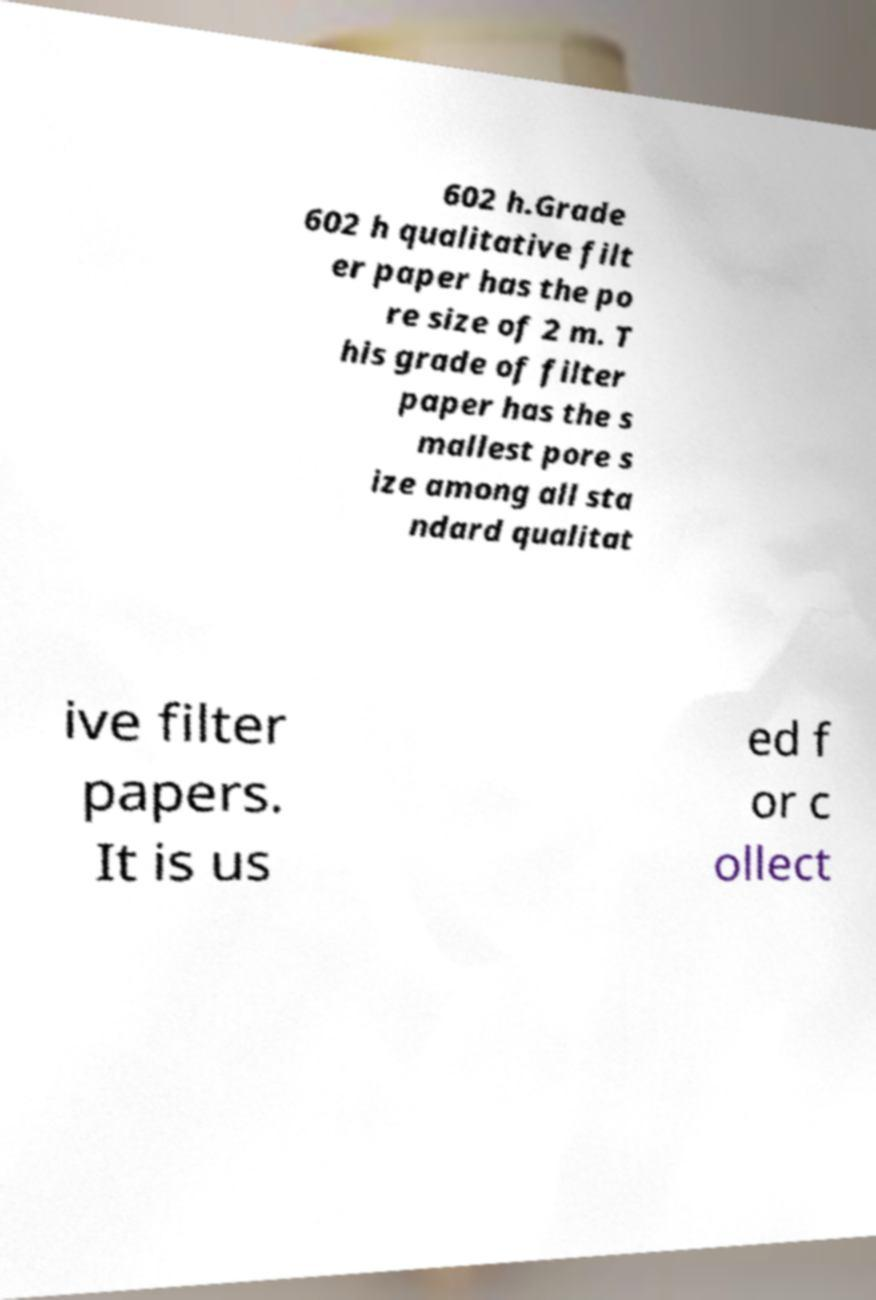I need the written content from this picture converted into text. Can you do that? 602 h.Grade 602 h qualitative filt er paper has the po re size of 2 m. T his grade of filter paper has the s mallest pore s ize among all sta ndard qualitat ive filter papers. It is us ed f or c ollect 